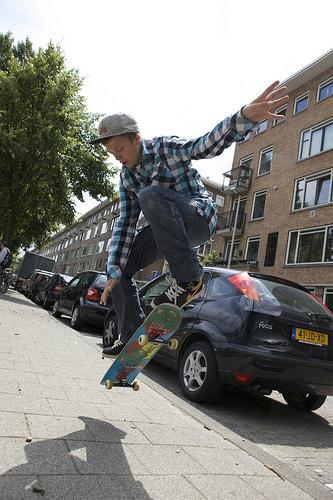What is the main activity occurring in the image? A young person is performing a trick on a skateboard in midair. Demonstrate a relationship between two objects in the image. The young skateboarder and the colorful skateboard are interacting as the skateboarder performs a jump in midair. Identify the primary object used by the main subject in the picture. The main object used by the subject is a colorful skateboard. Comment on the architectural elements present in the image. The image features a brick apartment building with balconies in the background. Assess the sentiment or overall mood conveyed by the image. The image conveys a sense of excitement and energy as the young skateboarder performs a trick. What is the surface the skateboard is above? Also, mention any prominent features of the surface. The skateboard is above a stone sidewalk, with the boy's shadow visible on the ground. Provide a brief description of the skateboarder's outfit. The skateboarder is wearing a plaid shirt, denim jeans, a gray baseball cap, and black tennis shoes. Explain the presence of trees in the image. There is a green tree on the right side of the image. How many cars are parked in the image and what is unique about one of them? There are several cars parked, and one car has a yellow license plate. Count the number of distinct shirts mentioned in the image. There are 3 distinct shirts mentioned: plaid shirt, black blue and white striped shirt, and blue and white patterned shirt. Is the boy wearing a red jacket while skating on the skateboard? The boy is not wearing a red jacket, but a blue checkered shirt. Is there a red car parked in front of the brick apartment building? There is no mention of a red car in the image, only three black cars are mentioned. Can you see a white bicycle parked next to the row of cars on the street? There is no mention of a bicycle in the image, only cars parked along the sidewalk. Is the boy wearing a helmet while performing the trick on his skateboard? The boy is wearing a grey hat, not a helmet. Is there a large purple tree in the middle of the image? There is a green tree on the right side of the image, not a purple one in the middle. Does the skateboard have black wheels? The skateboard mentioned in the image has white wheels, not black ones. 